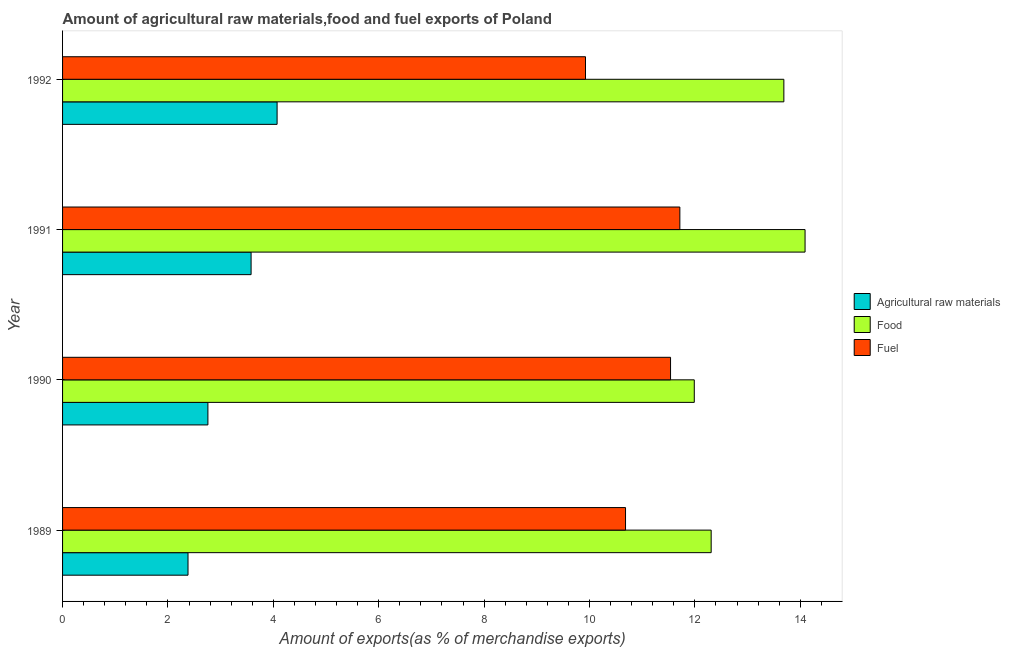How many groups of bars are there?
Provide a succinct answer. 4. What is the label of the 4th group of bars from the top?
Offer a terse response. 1989. In how many cases, is the number of bars for a given year not equal to the number of legend labels?
Offer a very short reply. 0. What is the percentage of fuel exports in 1991?
Give a very brief answer. 11.72. Across all years, what is the maximum percentage of fuel exports?
Your answer should be very brief. 11.72. Across all years, what is the minimum percentage of raw materials exports?
Give a very brief answer. 2.38. In which year was the percentage of fuel exports minimum?
Your answer should be compact. 1992. What is the total percentage of raw materials exports in the graph?
Your answer should be very brief. 12.79. What is the difference between the percentage of raw materials exports in 1989 and that in 1991?
Keep it short and to the point. -1.2. What is the difference between the percentage of food exports in 1991 and the percentage of fuel exports in 1990?
Ensure brevity in your answer.  2.55. What is the average percentage of raw materials exports per year?
Offer a very short reply. 3.2. In the year 1990, what is the difference between the percentage of food exports and percentage of raw materials exports?
Give a very brief answer. 9.23. What is the ratio of the percentage of fuel exports in 1989 to that in 1992?
Your answer should be very brief. 1.08. What is the difference between the highest and the second highest percentage of food exports?
Offer a very short reply. 0.4. What is the difference between the highest and the lowest percentage of fuel exports?
Provide a short and direct response. 1.79. Is the sum of the percentage of raw materials exports in 1989 and 1992 greater than the maximum percentage of food exports across all years?
Offer a terse response. No. What does the 3rd bar from the top in 1992 represents?
Your answer should be very brief. Agricultural raw materials. What does the 2nd bar from the bottom in 1991 represents?
Make the answer very short. Food. How many bars are there?
Your response must be concise. 12. Are all the bars in the graph horizontal?
Offer a very short reply. Yes. How many years are there in the graph?
Ensure brevity in your answer.  4. What is the difference between two consecutive major ticks on the X-axis?
Give a very brief answer. 2. Are the values on the major ticks of X-axis written in scientific E-notation?
Offer a terse response. No. Does the graph contain any zero values?
Your response must be concise. No. Does the graph contain grids?
Keep it short and to the point. No. How are the legend labels stacked?
Offer a very short reply. Vertical. What is the title of the graph?
Your answer should be very brief. Amount of agricultural raw materials,food and fuel exports of Poland. Does "Tertiary education" appear as one of the legend labels in the graph?
Give a very brief answer. No. What is the label or title of the X-axis?
Make the answer very short. Amount of exports(as % of merchandise exports). What is the label or title of the Y-axis?
Ensure brevity in your answer.  Year. What is the Amount of exports(as % of merchandise exports) of Agricultural raw materials in 1989?
Provide a succinct answer. 2.38. What is the Amount of exports(as % of merchandise exports) of Food in 1989?
Make the answer very short. 12.31. What is the Amount of exports(as % of merchandise exports) in Fuel in 1989?
Make the answer very short. 10.68. What is the Amount of exports(as % of merchandise exports) in Agricultural raw materials in 1990?
Ensure brevity in your answer.  2.76. What is the Amount of exports(as % of merchandise exports) of Food in 1990?
Your response must be concise. 11.99. What is the Amount of exports(as % of merchandise exports) of Fuel in 1990?
Your answer should be very brief. 11.54. What is the Amount of exports(as % of merchandise exports) of Agricultural raw materials in 1991?
Provide a succinct answer. 3.58. What is the Amount of exports(as % of merchandise exports) in Food in 1991?
Ensure brevity in your answer.  14.09. What is the Amount of exports(as % of merchandise exports) of Fuel in 1991?
Ensure brevity in your answer.  11.72. What is the Amount of exports(as % of merchandise exports) in Agricultural raw materials in 1992?
Provide a short and direct response. 4.07. What is the Amount of exports(as % of merchandise exports) in Food in 1992?
Give a very brief answer. 13.69. What is the Amount of exports(as % of merchandise exports) of Fuel in 1992?
Provide a short and direct response. 9.92. Across all years, what is the maximum Amount of exports(as % of merchandise exports) of Agricultural raw materials?
Make the answer very short. 4.07. Across all years, what is the maximum Amount of exports(as % of merchandise exports) in Food?
Your answer should be compact. 14.09. Across all years, what is the maximum Amount of exports(as % of merchandise exports) of Fuel?
Offer a very short reply. 11.72. Across all years, what is the minimum Amount of exports(as % of merchandise exports) of Agricultural raw materials?
Your response must be concise. 2.38. Across all years, what is the minimum Amount of exports(as % of merchandise exports) in Food?
Offer a terse response. 11.99. Across all years, what is the minimum Amount of exports(as % of merchandise exports) in Fuel?
Your answer should be compact. 9.92. What is the total Amount of exports(as % of merchandise exports) in Agricultural raw materials in the graph?
Offer a terse response. 12.79. What is the total Amount of exports(as % of merchandise exports) of Food in the graph?
Keep it short and to the point. 52.08. What is the total Amount of exports(as % of merchandise exports) in Fuel in the graph?
Provide a short and direct response. 43.86. What is the difference between the Amount of exports(as % of merchandise exports) in Agricultural raw materials in 1989 and that in 1990?
Provide a short and direct response. -0.38. What is the difference between the Amount of exports(as % of merchandise exports) in Food in 1989 and that in 1990?
Provide a short and direct response. 0.32. What is the difference between the Amount of exports(as % of merchandise exports) in Fuel in 1989 and that in 1990?
Your answer should be very brief. -0.85. What is the difference between the Amount of exports(as % of merchandise exports) of Agricultural raw materials in 1989 and that in 1991?
Provide a short and direct response. -1.2. What is the difference between the Amount of exports(as % of merchandise exports) of Food in 1989 and that in 1991?
Offer a very short reply. -1.78. What is the difference between the Amount of exports(as % of merchandise exports) in Fuel in 1989 and that in 1991?
Offer a very short reply. -1.03. What is the difference between the Amount of exports(as % of merchandise exports) of Agricultural raw materials in 1989 and that in 1992?
Your answer should be compact. -1.69. What is the difference between the Amount of exports(as % of merchandise exports) in Food in 1989 and that in 1992?
Provide a succinct answer. -1.38. What is the difference between the Amount of exports(as % of merchandise exports) of Fuel in 1989 and that in 1992?
Provide a succinct answer. 0.76. What is the difference between the Amount of exports(as % of merchandise exports) in Agricultural raw materials in 1990 and that in 1991?
Your response must be concise. -0.82. What is the difference between the Amount of exports(as % of merchandise exports) in Food in 1990 and that in 1991?
Ensure brevity in your answer.  -2.1. What is the difference between the Amount of exports(as % of merchandise exports) in Fuel in 1990 and that in 1991?
Offer a terse response. -0.18. What is the difference between the Amount of exports(as % of merchandise exports) in Agricultural raw materials in 1990 and that in 1992?
Provide a succinct answer. -1.31. What is the difference between the Amount of exports(as % of merchandise exports) in Food in 1990 and that in 1992?
Give a very brief answer. -1.7. What is the difference between the Amount of exports(as % of merchandise exports) in Fuel in 1990 and that in 1992?
Give a very brief answer. 1.61. What is the difference between the Amount of exports(as % of merchandise exports) in Agricultural raw materials in 1991 and that in 1992?
Ensure brevity in your answer.  -0.49. What is the difference between the Amount of exports(as % of merchandise exports) of Food in 1991 and that in 1992?
Offer a terse response. 0.4. What is the difference between the Amount of exports(as % of merchandise exports) in Fuel in 1991 and that in 1992?
Offer a very short reply. 1.79. What is the difference between the Amount of exports(as % of merchandise exports) of Agricultural raw materials in 1989 and the Amount of exports(as % of merchandise exports) of Food in 1990?
Give a very brief answer. -9.61. What is the difference between the Amount of exports(as % of merchandise exports) in Agricultural raw materials in 1989 and the Amount of exports(as % of merchandise exports) in Fuel in 1990?
Provide a short and direct response. -9.16. What is the difference between the Amount of exports(as % of merchandise exports) in Food in 1989 and the Amount of exports(as % of merchandise exports) in Fuel in 1990?
Provide a succinct answer. 0.77. What is the difference between the Amount of exports(as % of merchandise exports) of Agricultural raw materials in 1989 and the Amount of exports(as % of merchandise exports) of Food in 1991?
Your answer should be very brief. -11.71. What is the difference between the Amount of exports(as % of merchandise exports) of Agricultural raw materials in 1989 and the Amount of exports(as % of merchandise exports) of Fuel in 1991?
Your response must be concise. -9.33. What is the difference between the Amount of exports(as % of merchandise exports) in Food in 1989 and the Amount of exports(as % of merchandise exports) in Fuel in 1991?
Your answer should be very brief. 0.59. What is the difference between the Amount of exports(as % of merchandise exports) of Agricultural raw materials in 1989 and the Amount of exports(as % of merchandise exports) of Food in 1992?
Make the answer very short. -11.31. What is the difference between the Amount of exports(as % of merchandise exports) of Agricultural raw materials in 1989 and the Amount of exports(as % of merchandise exports) of Fuel in 1992?
Offer a terse response. -7.54. What is the difference between the Amount of exports(as % of merchandise exports) in Food in 1989 and the Amount of exports(as % of merchandise exports) in Fuel in 1992?
Provide a succinct answer. 2.38. What is the difference between the Amount of exports(as % of merchandise exports) of Agricultural raw materials in 1990 and the Amount of exports(as % of merchandise exports) of Food in 1991?
Your answer should be compact. -11.33. What is the difference between the Amount of exports(as % of merchandise exports) of Agricultural raw materials in 1990 and the Amount of exports(as % of merchandise exports) of Fuel in 1991?
Offer a terse response. -8.96. What is the difference between the Amount of exports(as % of merchandise exports) of Food in 1990 and the Amount of exports(as % of merchandise exports) of Fuel in 1991?
Provide a short and direct response. 0.27. What is the difference between the Amount of exports(as % of merchandise exports) in Agricultural raw materials in 1990 and the Amount of exports(as % of merchandise exports) in Food in 1992?
Give a very brief answer. -10.93. What is the difference between the Amount of exports(as % of merchandise exports) of Agricultural raw materials in 1990 and the Amount of exports(as % of merchandise exports) of Fuel in 1992?
Provide a succinct answer. -7.17. What is the difference between the Amount of exports(as % of merchandise exports) in Food in 1990 and the Amount of exports(as % of merchandise exports) in Fuel in 1992?
Offer a terse response. 2.06. What is the difference between the Amount of exports(as % of merchandise exports) in Agricultural raw materials in 1991 and the Amount of exports(as % of merchandise exports) in Food in 1992?
Provide a short and direct response. -10.11. What is the difference between the Amount of exports(as % of merchandise exports) in Agricultural raw materials in 1991 and the Amount of exports(as % of merchandise exports) in Fuel in 1992?
Provide a succinct answer. -6.35. What is the difference between the Amount of exports(as % of merchandise exports) in Food in 1991 and the Amount of exports(as % of merchandise exports) in Fuel in 1992?
Your response must be concise. 4.17. What is the average Amount of exports(as % of merchandise exports) of Agricultural raw materials per year?
Give a very brief answer. 3.2. What is the average Amount of exports(as % of merchandise exports) of Food per year?
Keep it short and to the point. 13.02. What is the average Amount of exports(as % of merchandise exports) of Fuel per year?
Give a very brief answer. 10.97. In the year 1989, what is the difference between the Amount of exports(as % of merchandise exports) in Agricultural raw materials and Amount of exports(as % of merchandise exports) in Food?
Offer a very short reply. -9.93. In the year 1989, what is the difference between the Amount of exports(as % of merchandise exports) of Agricultural raw materials and Amount of exports(as % of merchandise exports) of Fuel?
Your answer should be compact. -8.3. In the year 1989, what is the difference between the Amount of exports(as % of merchandise exports) in Food and Amount of exports(as % of merchandise exports) in Fuel?
Provide a succinct answer. 1.63. In the year 1990, what is the difference between the Amount of exports(as % of merchandise exports) of Agricultural raw materials and Amount of exports(as % of merchandise exports) of Food?
Provide a succinct answer. -9.23. In the year 1990, what is the difference between the Amount of exports(as % of merchandise exports) of Agricultural raw materials and Amount of exports(as % of merchandise exports) of Fuel?
Provide a short and direct response. -8.78. In the year 1990, what is the difference between the Amount of exports(as % of merchandise exports) of Food and Amount of exports(as % of merchandise exports) of Fuel?
Offer a very short reply. 0.45. In the year 1991, what is the difference between the Amount of exports(as % of merchandise exports) in Agricultural raw materials and Amount of exports(as % of merchandise exports) in Food?
Provide a short and direct response. -10.51. In the year 1991, what is the difference between the Amount of exports(as % of merchandise exports) of Agricultural raw materials and Amount of exports(as % of merchandise exports) of Fuel?
Provide a succinct answer. -8.14. In the year 1991, what is the difference between the Amount of exports(as % of merchandise exports) in Food and Amount of exports(as % of merchandise exports) in Fuel?
Provide a short and direct response. 2.38. In the year 1992, what is the difference between the Amount of exports(as % of merchandise exports) of Agricultural raw materials and Amount of exports(as % of merchandise exports) of Food?
Offer a terse response. -9.62. In the year 1992, what is the difference between the Amount of exports(as % of merchandise exports) of Agricultural raw materials and Amount of exports(as % of merchandise exports) of Fuel?
Provide a short and direct response. -5.85. In the year 1992, what is the difference between the Amount of exports(as % of merchandise exports) in Food and Amount of exports(as % of merchandise exports) in Fuel?
Your response must be concise. 3.76. What is the ratio of the Amount of exports(as % of merchandise exports) in Agricultural raw materials in 1989 to that in 1990?
Give a very brief answer. 0.86. What is the ratio of the Amount of exports(as % of merchandise exports) of Food in 1989 to that in 1990?
Keep it short and to the point. 1.03. What is the ratio of the Amount of exports(as % of merchandise exports) in Fuel in 1989 to that in 1990?
Make the answer very short. 0.93. What is the ratio of the Amount of exports(as % of merchandise exports) in Agricultural raw materials in 1989 to that in 1991?
Offer a terse response. 0.67. What is the ratio of the Amount of exports(as % of merchandise exports) in Food in 1989 to that in 1991?
Offer a very short reply. 0.87. What is the ratio of the Amount of exports(as % of merchandise exports) in Fuel in 1989 to that in 1991?
Provide a short and direct response. 0.91. What is the ratio of the Amount of exports(as % of merchandise exports) of Agricultural raw materials in 1989 to that in 1992?
Make the answer very short. 0.58. What is the ratio of the Amount of exports(as % of merchandise exports) of Food in 1989 to that in 1992?
Provide a short and direct response. 0.9. What is the ratio of the Amount of exports(as % of merchandise exports) in Fuel in 1989 to that in 1992?
Provide a short and direct response. 1.08. What is the ratio of the Amount of exports(as % of merchandise exports) in Agricultural raw materials in 1990 to that in 1991?
Provide a short and direct response. 0.77. What is the ratio of the Amount of exports(as % of merchandise exports) in Food in 1990 to that in 1991?
Offer a very short reply. 0.85. What is the ratio of the Amount of exports(as % of merchandise exports) in Fuel in 1990 to that in 1991?
Your answer should be very brief. 0.98. What is the ratio of the Amount of exports(as % of merchandise exports) in Agricultural raw materials in 1990 to that in 1992?
Offer a very short reply. 0.68. What is the ratio of the Amount of exports(as % of merchandise exports) of Food in 1990 to that in 1992?
Your answer should be compact. 0.88. What is the ratio of the Amount of exports(as % of merchandise exports) in Fuel in 1990 to that in 1992?
Keep it short and to the point. 1.16. What is the ratio of the Amount of exports(as % of merchandise exports) in Agricultural raw materials in 1991 to that in 1992?
Provide a succinct answer. 0.88. What is the ratio of the Amount of exports(as % of merchandise exports) in Food in 1991 to that in 1992?
Provide a succinct answer. 1.03. What is the ratio of the Amount of exports(as % of merchandise exports) of Fuel in 1991 to that in 1992?
Provide a short and direct response. 1.18. What is the difference between the highest and the second highest Amount of exports(as % of merchandise exports) of Agricultural raw materials?
Your answer should be very brief. 0.49. What is the difference between the highest and the second highest Amount of exports(as % of merchandise exports) of Food?
Keep it short and to the point. 0.4. What is the difference between the highest and the second highest Amount of exports(as % of merchandise exports) of Fuel?
Provide a succinct answer. 0.18. What is the difference between the highest and the lowest Amount of exports(as % of merchandise exports) of Agricultural raw materials?
Your response must be concise. 1.69. What is the difference between the highest and the lowest Amount of exports(as % of merchandise exports) of Food?
Keep it short and to the point. 2.1. What is the difference between the highest and the lowest Amount of exports(as % of merchandise exports) of Fuel?
Provide a short and direct response. 1.79. 